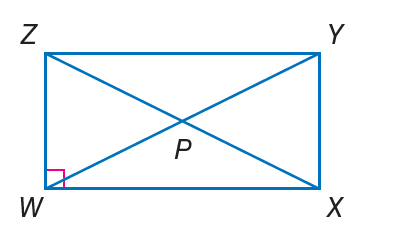Answer the mathemtical geometry problem and directly provide the correct option letter.
Question: If m \angle Z X W = x - 11 and m \angle W Z X = x - 9, find m \angle Z X Y.
Choices: A: 24 B: 46 C: 48 D: 96 B 